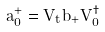<formula> <loc_0><loc_0><loc_500><loc_500>a _ { 0 } ^ { + } = V _ { t } b _ { + } V _ { 0 } ^ { \dag }</formula> 